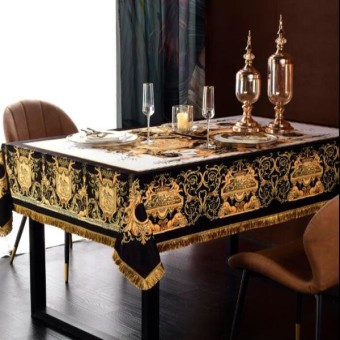Could you describe the setting this table might be used for? This table setting could suit a formal dinner event, such as an upscale party, a holiday celebration, or a fancy gathering where a high level of decorum and style is appreciated. The well-coordinated tableware and the presence of what appears to be wine glasses suggest a preparedness for a sophisticated dining experience. 